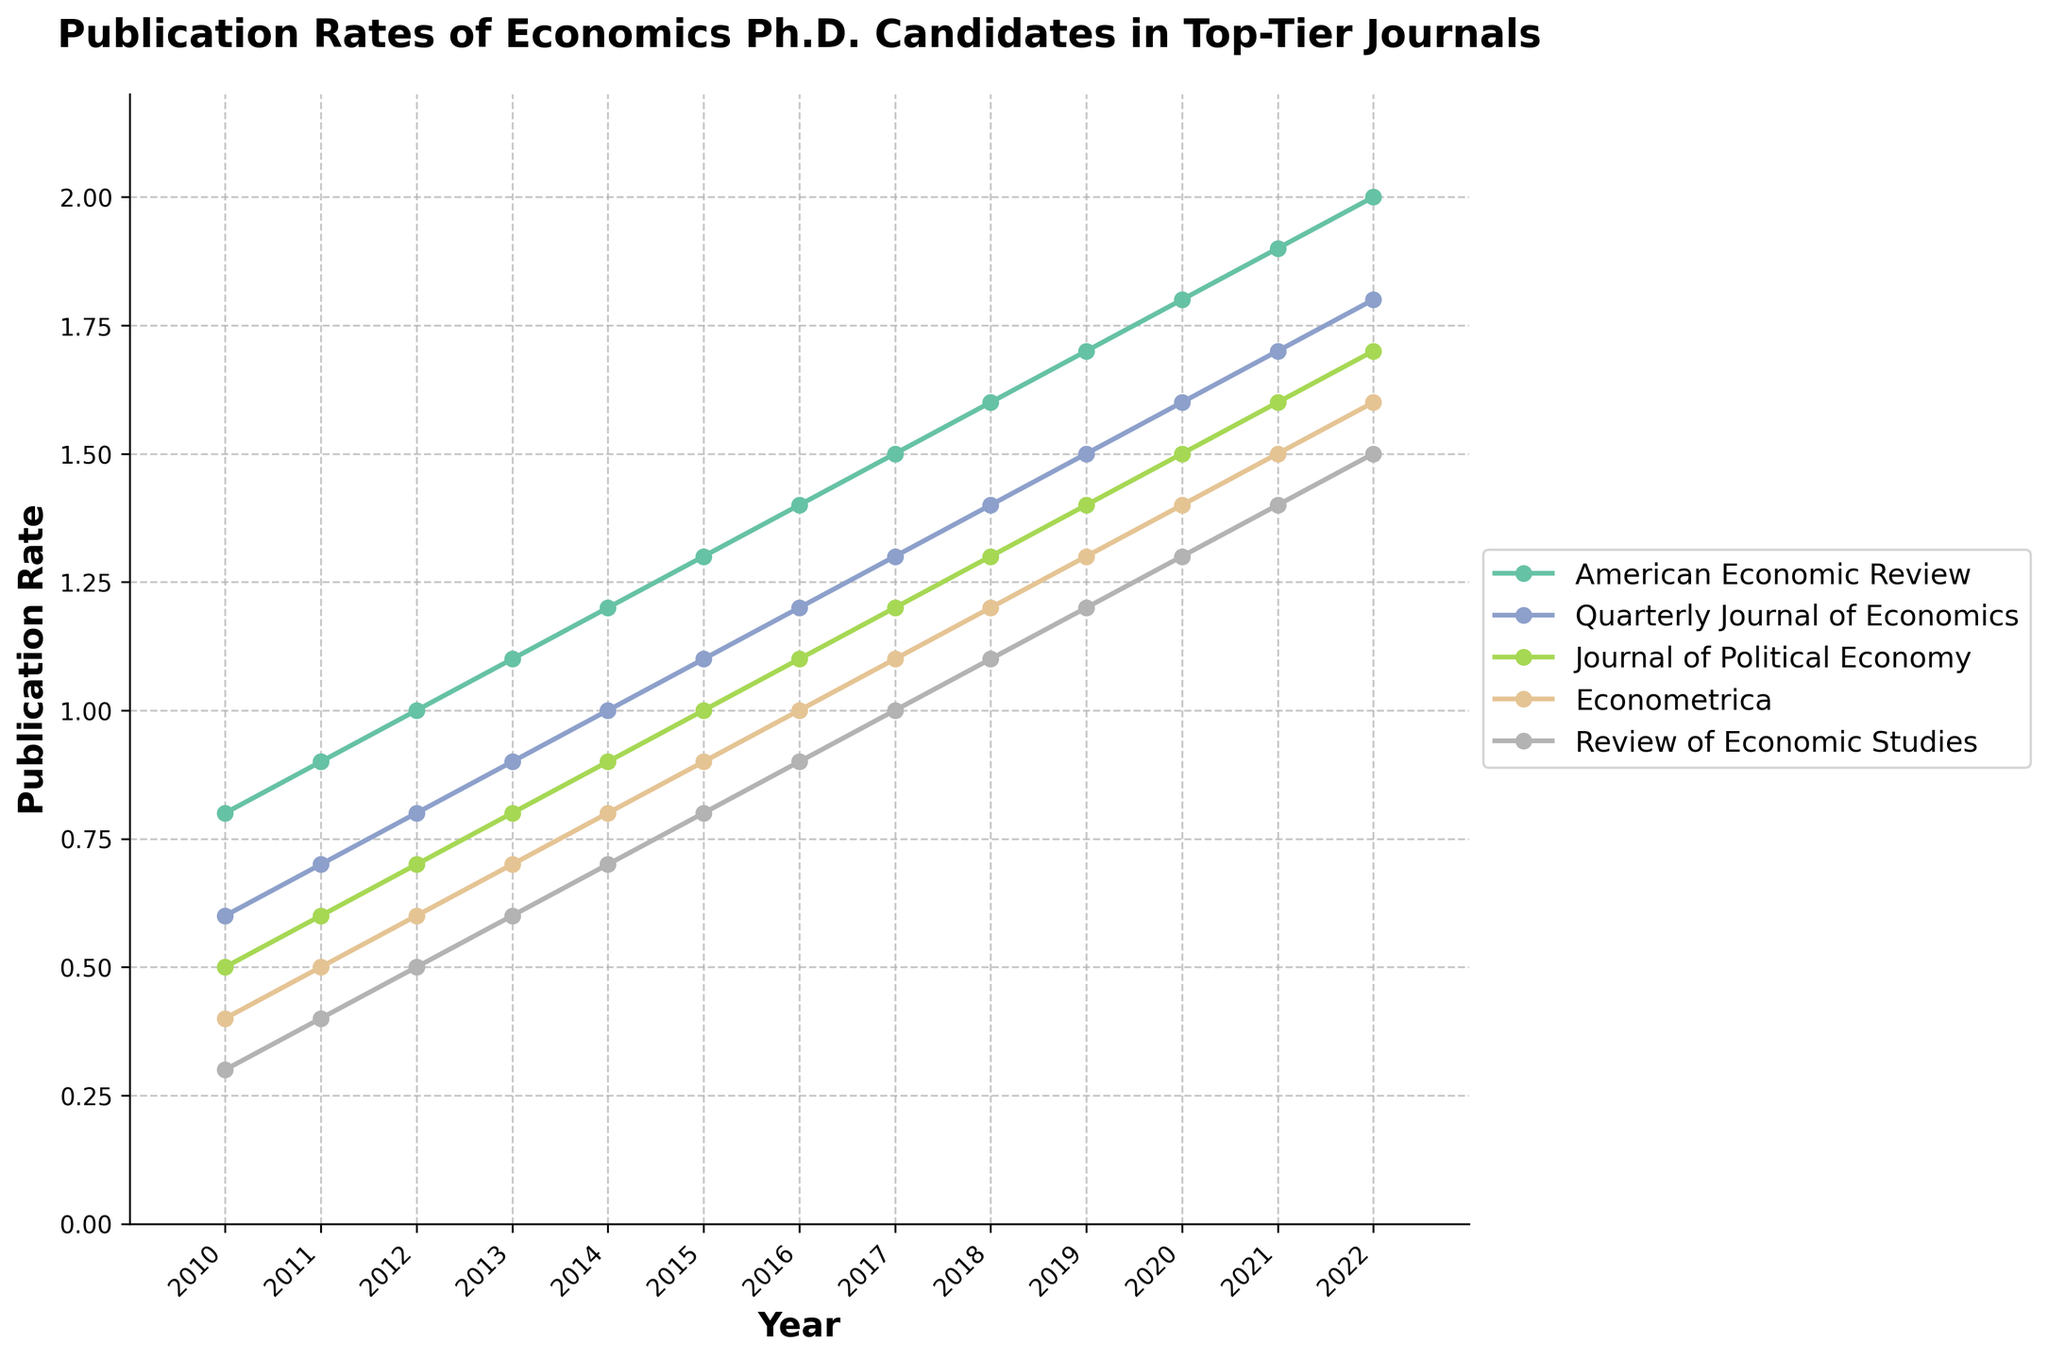What is the publication rate for the American Economic Review in 2015? The publication rate for the American Economic Review in 2015 can be read directly from the line chart by following the data point for 2015 on the x-axis and finding its corresponding y-value. The y-value for the American Economic Review in 2015 is increased by 0.1 each year from 2010, so in 2015, it is at 1.3.
Answer: 1.3 Which journal had the highest publication rate in 2022? To determine the journal with the highest publication rate in 2022, compare the y-values of each journal's line for the year 2022. The American Economic Review has the highest publication rate among all journals in 2022, at 2.0.
Answer: American Economic Review How much did the publication rate for the Quarterly Journal of Economics increase from 2010 to 2022? To find the increase in the publication rate, subtract the 2010 value from the 2022 value for the Quarterly Journal of Economics. In 2010, the rate was 0.6, and in 2022, it was 1.8. Thus, the increase is 1.8 - 0.6 = 1.2.
Answer: 1.2 In which year did the Journal of Political Economy first reach a publication rate of 1.0 or higher? To find the first year where the Journal of Political Economy's publication rate reaches or exceeds 1.0, trace the y-values from 2010 onwards. The y-value reaches 1.0 in 2015.
Answer: 2015 Compare the publication rates of the Econometrica and Review of Economic Studies in 2017. Which one was higher? In 2017, locate the publication rates for both Econometrica and the Review of Economic Studies. For Econometrica, it is 1.1 and for the Review of Economic Studies, it is 1.0. Hence, Econometrica had the higher publication rate.
Answer: Econometrica What is the average publication rate for all journals in 2018? To find the average publication rate for all journals in 2018, sum up the publication rates of all five journals in that year and divide by the number of journals. The rates are: 1.6 + 1.4 + 1.3 + 1.2 + 1.1 = 6.6. Dividing by 5 gives 6.6 / 5 = 1.32.
Answer: 1.32 Was there any year when the publication rate for the Review of Economic Studies was exactly 1.0? If yes, which year? Check the all yearly publication rates for the Review of Economic Studies to see if any of them is exactly 1.0. In 2017, the publication rate was exactly 1.0.
Answer: 2017 Which journal had the smallest increase in publication rate from 2011 to 2012? Determine the increase in publication rate for each journal from 2011 to 2012 by subtracting the 2011 value from the 2012 value for each. The increases are: American Economic Review (0.1), Quarterly Journal of Economics (0.1), Journal of Political Economy (0.1), Econometrica (0.1), and Review of Economic Studies (0.1). All journals had the same increase of 0.1.
Answer: All journals had the same increase By how much did the publication rate for the American Economic Review grow from 2015 to 2020? Subtract the publication rate for the American Economic Review in 2015 from its publication rate in 2020. The values are 1.8 in 2020 and 1.3 in 2015. The difference is 1.8 - 1.3 = 0.5.
Answer: 0.5 